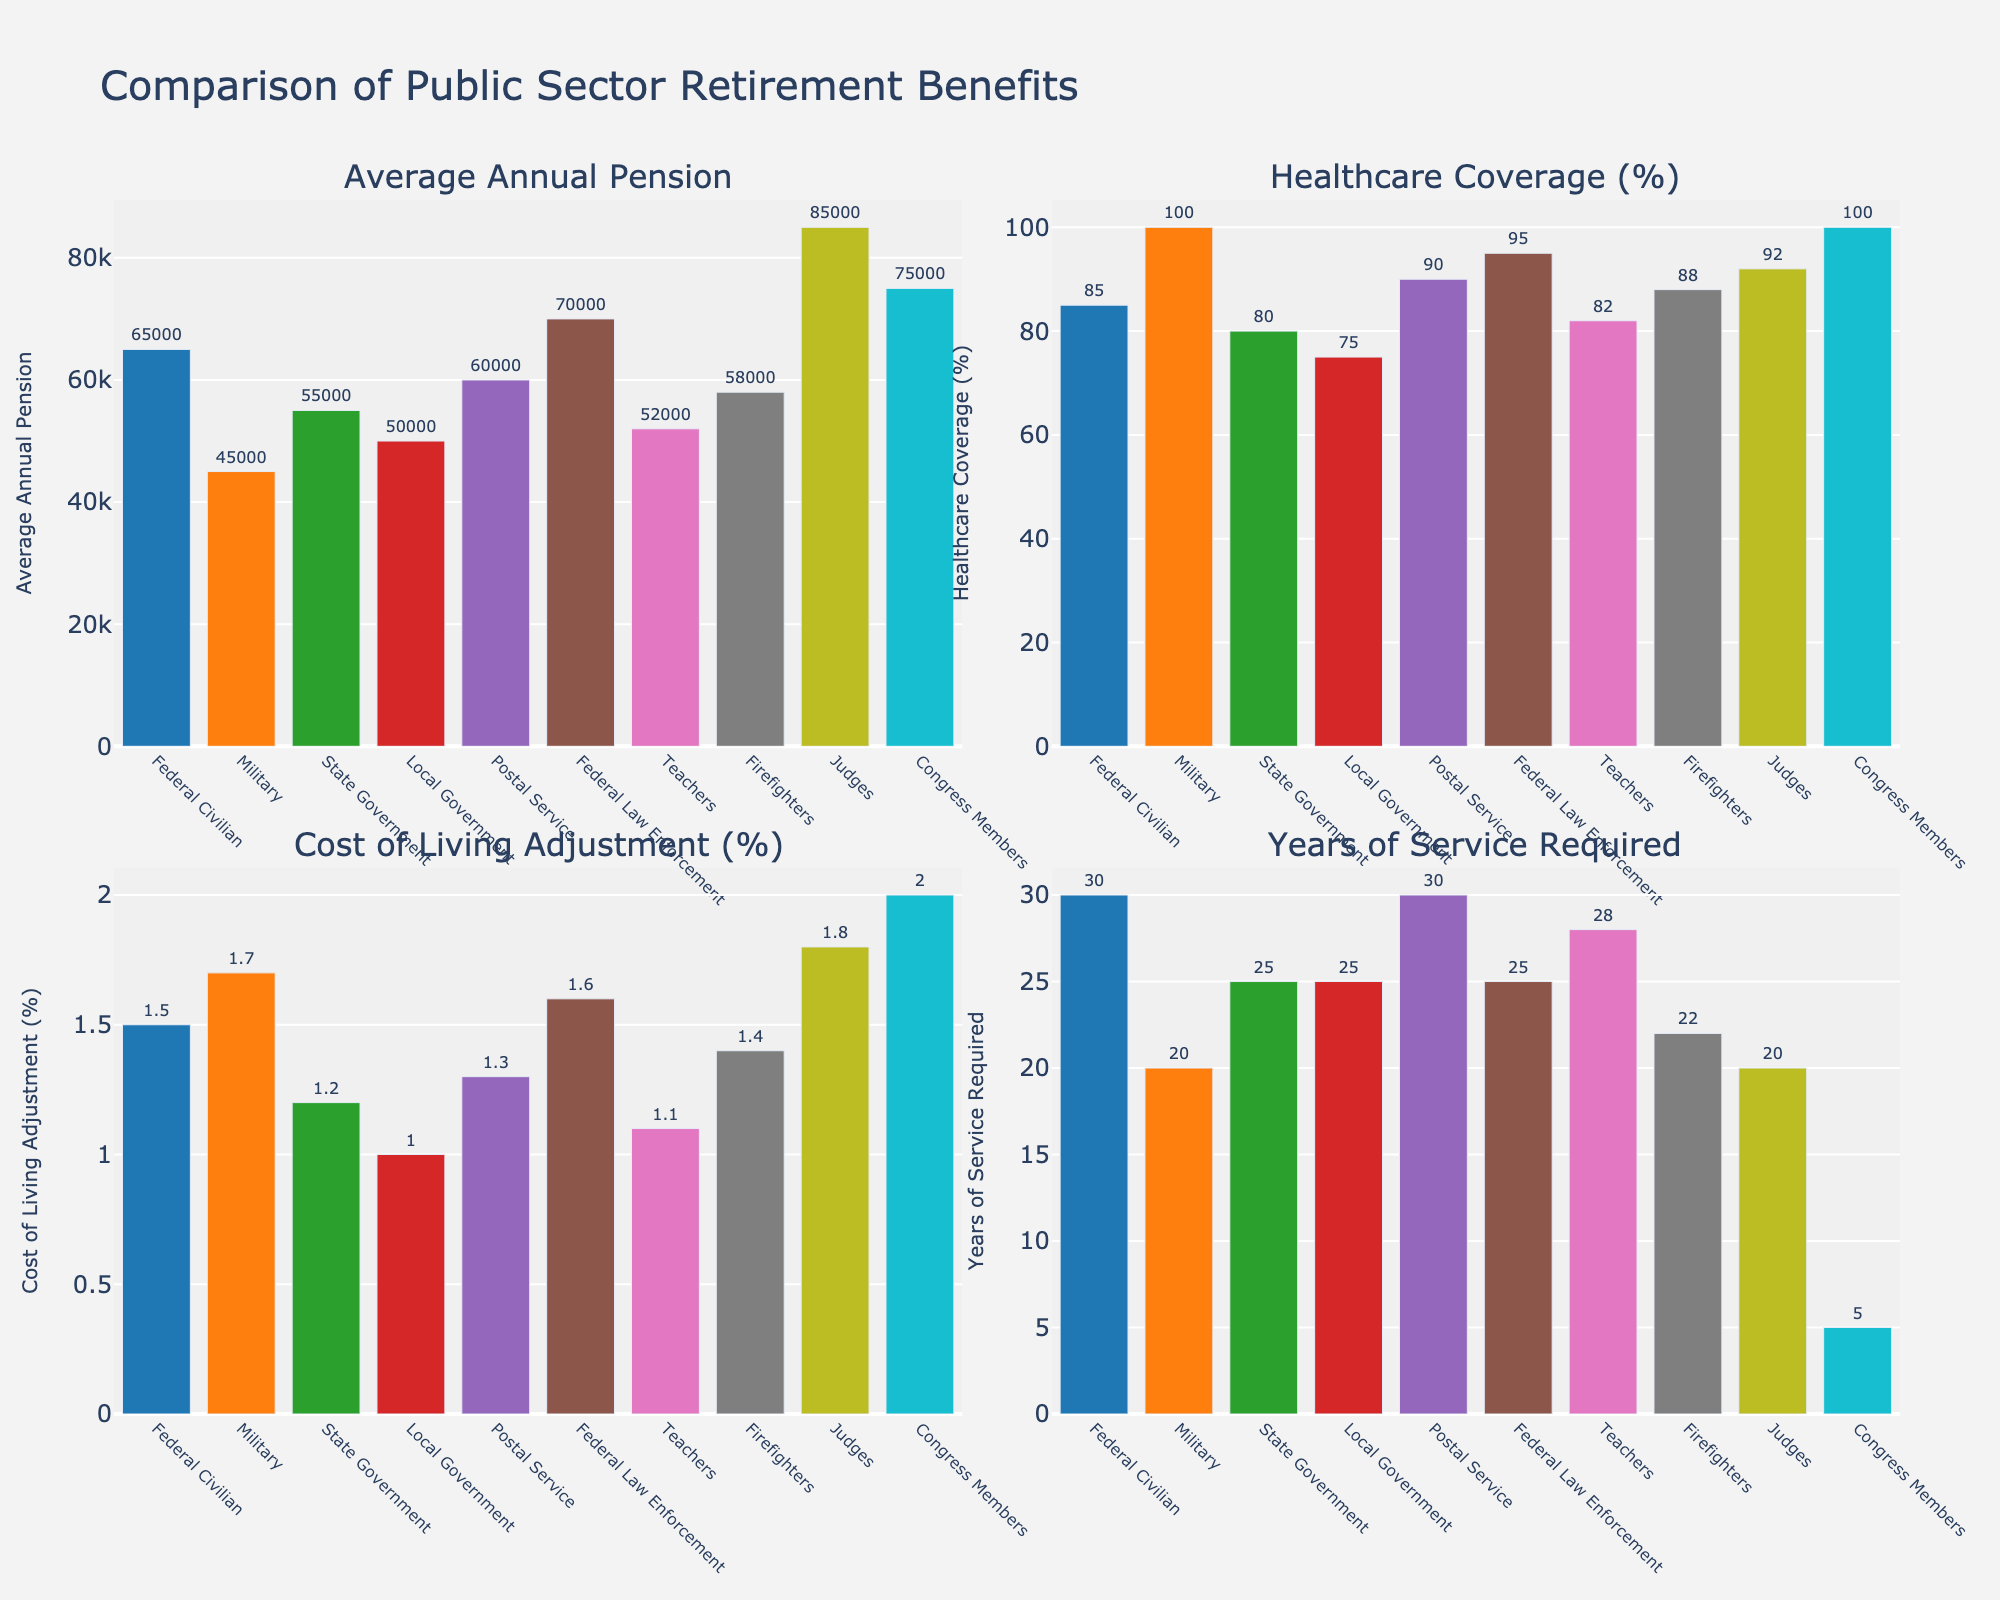what is the difference in the average annual pension between the top two agencies? The two agencies with the highest 'Average Annual Pension' are Judges ($85,000) and Congress Members ($75,000). The difference is $85,000 - $75,000 = $10,000.
Answer: $10,000 which agency offers the highest healthcare coverage percentage? The agency with the highest 'Healthcare Coverage (%)' bar is the Military and Congress Members, both with 100%.
Answer: Military and Congress Members how many agencies require more than 25 years of service? The figure shows the 'Years of Service Required' for each agency. Federal Civilian (30), Postal Service (30), Teachers (28), and Local Government (25) all require more than 25 years. This sums to 4.
Answer: 4 which agency offers the highest cost of living adjustment and what is its value? The 'Cost of Living Adjustment (%)' bars indicate that Congress Members have the highest value at 2.0%.
Answer: Congress Members, 2.0% compare the healthcare coverage percentage between firefighters and federal civilian employees. Firefighters have 88% healthcare coverage, and Federal Civilian employees have 85%. The difference is 88% - 85% = 3%.
Answer: Firefighters have 3% higher healthcare coverage than Federal Civilian employees which agency has the lowest pension, and what is the corresponding value? By comparing the 'Average Annual Pension' bars, the Military has the lowest pension value of $45,000.
Answer: Military, $45,000 what is the combined value of cost of living adjustments for state government and teachers? The state government has a 1.2% adjustment, and teachers have 1.1%. Adding these together, 1.2% + 1.1% = 2.3%.
Answer: 2.3% what is the easiest agency for reaching retirement eligibility in terms of years of service? The 'Years of Service Required' bars indicate that Congress Members require the fewest years, at 5 years.
Answer: Congress Members which agency provides the highest Average Annual Pension and what percentage of their healthcare is covered? Judges provide the highest 'Average Annual Pension' at $85,000, with 92% healthcare coverage.
Answer: Judges, 92% how does the healthcare coverage for postal service employees compare to firefighters? Postal Service has 90% healthcare coverage, whereas Firefighters have 88%. So Postal Service covers 2% more.
Answer: Postal Service, 2% more 